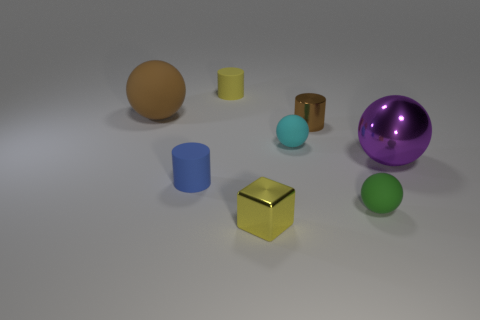Add 1 large red matte objects. How many objects exist? 9 Subtract all large purple spheres. How many spheres are left? 3 Subtract all blocks. How many objects are left? 7 Subtract 3 balls. How many balls are left? 1 Add 1 tiny yellow metallic spheres. How many tiny yellow metallic spheres exist? 1 Subtract all blue cylinders. How many cylinders are left? 2 Subtract 1 blue cylinders. How many objects are left? 7 Subtract all blue spheres. Subtract all brown cubes. How many spheres are left? 4 Subtract all small yellow shiny objects. Subtract all big purple shiny things. How many objects are left? 6 Add 6 small yellow metal cubes. How many small yellow metal cubes are left? 7 